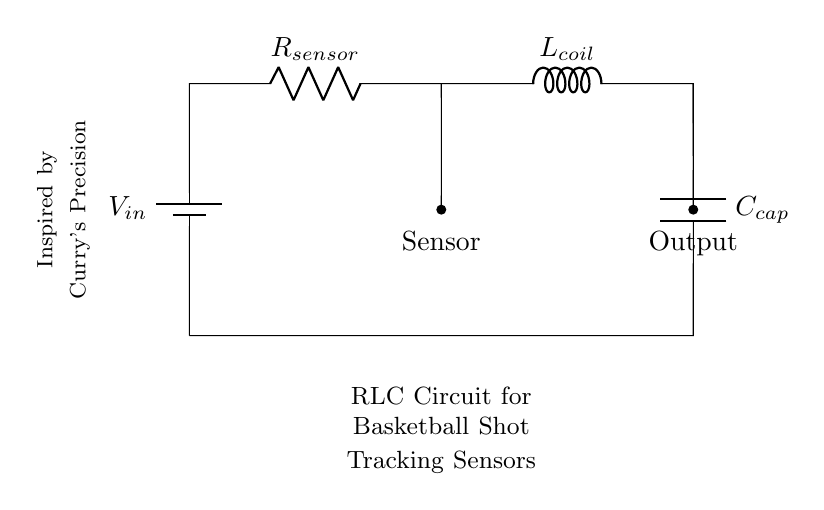What is the input voltage of this circuit? The input voltage is represented by \( V_{in} \), which is typically shown on the left side of the circuit diagram.
Answer: \( V_{in} \) What component is represented by \( R_{sensor} \)? The component labeled \( R_{sensor} \) in the diagram indicates a resistor that is likely used for sensing purposes in the shot tracking application.
Answer: Resistor What type of circuit is this? This circuit is a Resistor-Inductor-Capacitor (RLC) circuit, which involves a combination of these three components to create a dynamic response.
Answer: RLC Circuit What does \( L_{coil} \) represent in the circuit? \( L_{coil} \) refers to the inductor in the circuit, which is placed to store energy in the magnetic field when current passes through it.
Answer: Inductor Which component produces the output signal? The output is taken from the node connected to the capacitor \( C_{cap} \) as shown, indicating that it likely provides data for shot tracking feedback.
Answer: Capacitor What is the purpose of the \( C_{cap} \) in this circuit? The capacitor \( C_{cap} \) charges and discharges to smooth out the signal from the inductor and resistor, thus enhancing the accuracy of the tracking sensor feedback.
Answer: Capacitor What component would you expect to handle feedback from the sensor? The sensor is connected to the resistor \( R_{sensor} \), which would handle and process the feedback from the basketball shot for the tracking system.
Answer: Resistor 